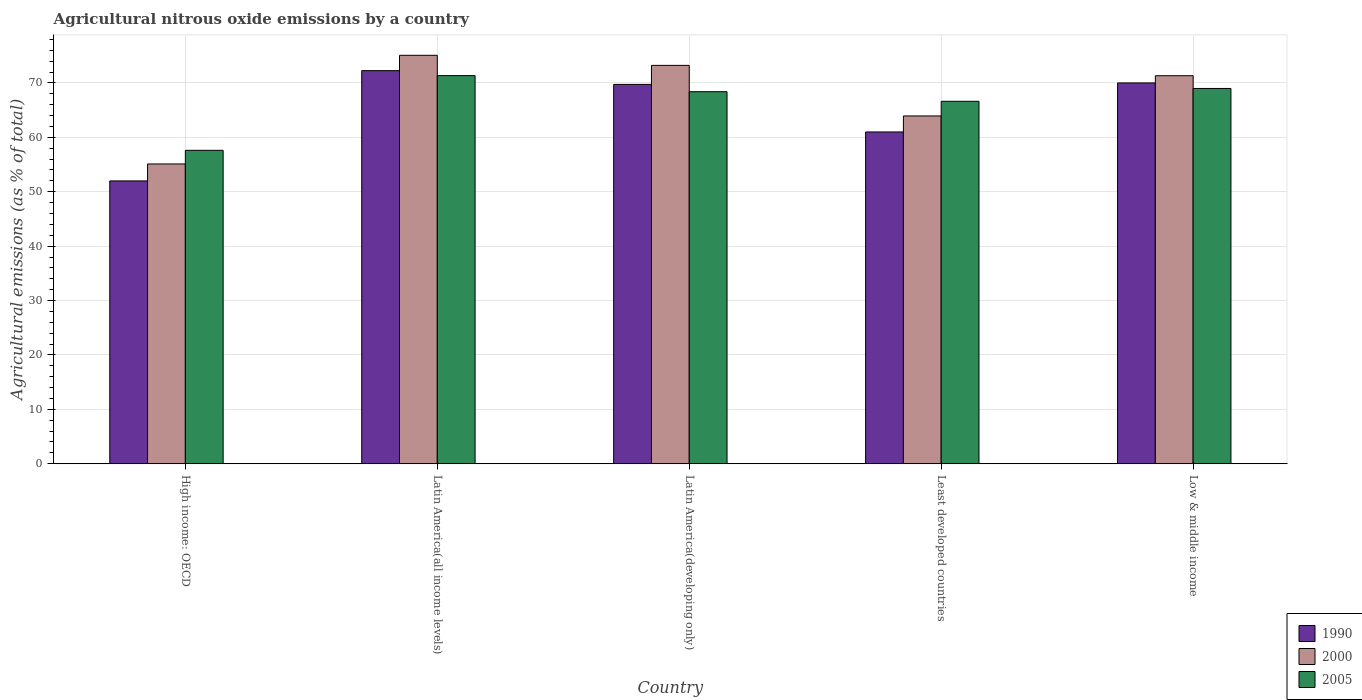How many different coloured bars are there?
Keep it short and to the point. 3. Are the number of bars on each tick of the X-axis equal?
Your answer should be compact. Yes. How many bars are there on the 2nd tick from the left?
Offer a terse response. 3. How many bars are there on the 1st tick from the right?
Your answer should be very brief. 3. What is the label of the 5th group of bars from the left?
Provide a short and direct response. Low & middle income. In how many cases, is the number of bars for a given country not equal to the number of legend labels?
Offer a very short reply. 0. What is the amount of agricultural nitrous oxide emitted in 2000 in Least developed countries?
Your answer should be compact. 63.93. Across all countries, what is the maximum amount of agricultural nitrous oxide emitted in 2000?
Provide a short and direct response. 75.08. Across all countries, what is the minimum amount of agricultural nitrous oxide emitted in 2000?
Make the answer very short. 55.1. In which country was the amount of agricultural nitrous oxide emitted in 2000 maximum?
Offer a very short reply. Latin America(all income levels). In which country was the amount of agricultural nitrous oxide emitted in 1990 minimum?
Keep it short and to the point. High income: OECD. What is the total amount of agricultural nitrous oxide emitted in 2000 in the graph?
Provide a succinct answer. 338.66. What is the difference between the amount of agricultural nitrous oxide emitted in 1990 in Latin America(all income levels) and that in Low & middle income?
Your response must be concise. 2.26. What is the difference between the amount of agricultural nitrous oxide emitted in 1990 in Least developed countries and the amount of agricultural nitrous oxide emitted in 2000 in Latin America(developing only)?
Your answer should be very brief. -12.24. What is the average amount of agricultural nitrous oxide emitted in 1990 per country?
Make the answer very short. 64.99. What is the difference between the amount of agricultural nitrous oxide emitted of/in 2005 and amount of agricultural nitrous oxide emitted of/in 2000 in Low & middle income?
Your answer should be compact. -2.34. What is the ratio of the amount of agricultural nitrous oxide emitted in 2005 in High income: OECD to that in Least developed countries?
Your response must be concise. 0.86. Is the difference between the amount of agricultural nitrous oxide emitted in 2005 in High income: OECD and Low & middle income greater than the difference between the amount of agricultural nitrous oxide emitted in 2000 in High income: OECD and Low & middle income?
Your response must be concise. Yes. What is the difference between the highest and the second highest amount of agricultural nitrous oxide emitted in 1990?
Keep it short and to the point. 2.53. What is the difference between the highest and the lowest amount of agricultural nitrous oxide emitted in 2000?
Provide a succinct answer. 19.97. Is the sum of the amount of agricultural nitrous oxide emitted in 2000 in High income: OECD and Latin America(all income levels) greater than the maximum amount of agricultural nitrous oxide emitted in 2005 across all countries?
Your response must be concise. Yes. What does the 1st bar from the left in Low & middle income represents?
Provide a succinct answer. 1990. What does the 1st bar from the right in High income: OECD represents?
Give a very brief answer. 2005. How many bars are there?
Make the answer very short. 15. Are the values on the major ticks of Y-axis written in scientific E-notation?
Provide a short and direct response. No. Does the graph contain grids?
Your answer should be compact. Yes. What is the title of the graph?
Make the answer very short. Agricultural nitrous oxide emissions by a country. What is the label or title of the Y-axis?
Your answer should be very brief. Agricultural emissions (as % of total). What is the Agricultural emissions (as % of total) of 1990 in High income: OECD?
Give a very brief answer. 51.99. What is the Agricultural emissions (as % of total) of 2000 in High income: OECD?
Offer a very short reply. 55.1. What is the Agricultural emissions (as % of total) in 2005 in High income: OECD?
Your answer should be very brief. 57.61. What is the Agricultural emissions (as % of total) in 1990 in Latin America(all income levels)?
Your answer should be compact. 72.26. What is the Agricultural emissions (as % of total) in 2000 in Latin America(all income levels)?
Make the answer very short. 75.08. What is the Agricultural emissions (as % of total) of 2005 in Latin America(all income levels)?
Ensure brevity in your answer.  71.34. What is the Agricultural emissions (as % of total) in 1990 in Latin America(developing only)?
Ensure brevity in your answer.  69.73. What is the Agricultural emissions (as % of total) in 2000 in Latin America(developing only)?
Keep it short and to the point. 73.22. What is the Agricultural emissions (as % of total) in 2005 in Latin America(developing only)?
Ensure brevity in your answer.  68.38. What is the Agricultural emissions (as % of total) of 1990 in Least developed countries?
Your answer should be very brief. 60.99. What is the Agricultural emissions (as % of total) of 2000 in Least developed countries?
Provide a short and direct response. 63.93. What is the Agricultural emissions (as % of total) of 2005 in Least developed countries?
Keep it short and to the point. 66.62. What is the Agricultural emissions (as % of total) in 1990 in Low & middle income?
Your answer should be compact. 70. What is the Agricultural emissions (as % of total) in 2000 in Low & middle income?
Offer a terse response. 71.32. What is the Agricultural emissions (as % of total) of 2005 in Low & middle income?
Your answer should be compact. 68.98. Across all countries, what is the maximum Agricultural emissions (as % of total) of 1990?
Give a very brief answer. 72.26. Across all countries, what is the maximum Agricultural emissions (as % of total) of 2000?
Give a very brief answer. 75.08. Across all countries, what is the maximum Agricultural emissions (as % of total) in 2005?
Offer a terse response. 71.34. Across all countries, what is the minimum Agricultural emissions (as % of total) in 1990?
Give a very brief answer. 51.99. Across all countries, what is the minimum Agricultural emissions (as % of total) in 2000?
Your answer should be compact. 55.1. Across all countries, what is the minimum Agricultural emissions (as % of total) of 2005?
Provide a succinct answer. 57.61. What is the total Agricultural emissions (as % of total) of 1990 in the graph?
Make the answer very short. 324.96. What is the total Agricultural emissions (as % of total) of 2000 in the graph?
Offer a terse response. 338.66. What is the total Agricultural emissions (as % of total) of 2005 in the graph?
Offer a terse response. 332.94. What is the difference between the Agricultural emissions (as % of total) of 1990 in High income: OECD and that in Latin America(all income levels)?
Your response must be concise. -20.27. What is the difference between the Agricultural emissions (as % of total) of 2000 in High income: OECD and that in Latin America(all income levels)?
Make the answer very short. -19.97. What is the difference between the Agricultural emissions (as % of total) of 2005 in High income: OECD and that in Latin America(all income levels)?
Offer a terse response. -13.73. What is the difference between the Agricultural emissions (as % of total) of 1990 in High income: OECD and that in Latin America(developing only)?
Offer a terse response. -17.74. What is the difference between the Agricultural emissions (as % of total) of 2000 in High income: OECD and that in Latin America(developing only)?
Give a very brief answer. -18.12. What is the difference between the Agricultural emissions (as % of total) in 2005 in High income: OECD and that in Latin America(developing only)?
Your answer should be compact. -10.77. What is the difference between the Agricultural emissions (as % of total) in 1990 in High income: OECD and that in Least developed countries?
Your response must be concise. -9. What is the difference between the Agricultural emissions (as % of total) in 2000 in High income: OECD and that in Least developed countries?
Your answer should be very brief. -8.82. What is the difference between the Agricultural emissions (as % of total) in 2005 in High income: OECD and that in Least developed countries?
Provide a short and direct response. -9.01. What is the difference between the Agricultural emissions (as % of total) in 1990 in High income: OECD and that in Low & middle income?
Provide a succinct answer. -18.01. What is the difference between the Agricultural emissions (as % of total) of 2000 in High income: OECD and that in Low & middle income?
Your response must be concise. -16.22. What is the difference between the Agricultural emissions (as % of total) in 2005 in High income: OECD and that in Low & middle income?
Make the answer very short. -11.37. What is the difference between the Agricultural emissions (as % of total) of 1990 in Latin America(all income levels) and that in Latin America(developing only)?
Make the answer very short. 2.53. What is the difference between the Agricultural emissions (as % of total) of 2000 in Latin America(all income levels) and that in Latin America(developing only)?
Offer a terse response. 1.86. What is the difference between the Agricultural emissions (as % of total) in 2005 in Latin America(all income levels) and that in Latin America(developing only)?
Provide a succinct answer. 2.96. What is the difference between the Agricultural emissions (as % of total) in 1990 in Latin America(all income levels) and that in Least developed countries?
Your answer should be compact. 11.27. What is the difference between the Agricultural emissions (as % of total) of 2000 in Latin America(all income levels) and that in Least developed countries?
Give a very brief answer. 11.15. What is the difference between the Agricultural emissions (as % of total) of 2005 in Latin America(all income levels) and that in Least developed countries?
Provide a succinct answer. 4.72. What is the difference between the Agricultural emissions (as % of total) of 1990 in Latin America(all income levels) and that in Low & middle income?
Give a very brief answer. 2.26. What is the difference between the Agricultural emissions (as % of total) in 2000 in Latin America(all income levels) and that in Low & middle income?
Give a very brief answer. 3.75. What is the difference between the Agricultural emissions (as % of total) of 2005 in Latin America(all income levels) and that in Low & middle income?
Offer a terse response. 2.36. What is the difference between the Agricultural emissions (as % of total) in 1990 in Latin America(developing only) and that in Least developed countries?
Your response must be concise. 8.74. What is the difference between the Agricultural emissions (as % of total) in 2000 in Latin America(developing only) and that in Least developed countries?
Your answer should be compact. 9.29. What is the difference between the Agricultural emissions (as % of total) of 2005 in Latin America(developing only) and that in Least developed countries?
Give a very brief answer. 1.76. What is the difference between the Agricultural emissions (as % of total) in 1990 in Latin America(developing only) and that in Low & middle income?
Keep it short and to the point. -0.27. What is the difference between the Agricultural emissions (as % of total) in 2000 in Latin America(developing only) and that in Low & middle income?
Provide a succinct answer. 1.9. What is the difference between the Agricultural emissions (as % of total) in 2005 in Latin America(developing only) and that in Low & middle income?
Your answer should be very brief. -0.6. What is the difference between the Agricultural emissions (as % of total) in 1990 in Least developed countries and that in Low & middle income?
Offer a very short reply. -9.01. What is the difference between the Agricultural emissions (as % of total) in 2000 in Least developed countries and that in Low & middle income?
Provide a short and direct response. -7.39. What is the difference between the Agricultural emissions (as % of total) of 2005 in Least developed countries and that in Low & middle income?
Offer a very short reply. -2.36. What is the difference between the Agricultural emissions (as % of total) in 1990 in High income: OECD and the Agricultural emissions (as % of total) in 2000 in Latin America(all income levels)?
Your answer should be very brief. -23.09. What is the difference between the Agricultural emissions (as % of total) in 1990 in High income: OECD and the Agricultural emissions (as % of total) in 2005 in Latin America(all income levels)?
Your answer should be very brief. -19.35. What is the difference between the Agricultural emissions (as % of total) in 2000 in High income: OECD and the Agricultural emissions (as % of total) in 2005 in Latin America(all income levels)?
Keep it short and to the point. -16.24. What is the difference between the Agricultural emissions (as % of total) in 1990 in High income: OECD and the Agricultural emissions (as % of total) in 2000 in Latin America(developing only)?
Provide a succinct answer. -21.23. What is the difference between the Agricultural emissions (as % of total) of 1990 in High income: OECD and the Agricultural emissions (as % of total) of 2005 in Latin America(developing only)?
Ensure brevity in your answer.  -16.39. What is the difference between the Agricultural emissions (as % of total) of 2000 in High income: OECD and the Agricultural emissions (as % of total) of 2005 in Latin America(developing only)?
Your answer should be very brief. -13.28. What is the difference between the Agricultural emissions (as % of total) of 1990 in High income: OECD and the Agricultural emissions (as % of total) of 2000 in Least developed countries?
Keep it short and to the point. -11.94. What is the difference between the Agricultural emissions (as % of total) of 1990 in High income: OECD and the Agricultural emissions (as % of total) of 2005 in Least developed countries?
Make the answer very short. -14.63. What is the difference between the Agricultural emissions (as % of total) in 2000 in High income: OECD and the Agricultural emissions (as % of total) in 2005 in Least developed countries?
Offer a terse response. -11.52. What is the difference between the Agricultural emissions (as % of total) in 1990 in High income: OECD and the Agricultural emissions (as % of total) in 2000 in Low & middle income?
Your answer should be very brief. -19.34. What is the difference between the Agricultural emissions (as % of total) in 1990 in High income: OECD and the Agricultural emissions (as % of total) in 2005 in Low & middle income?
Give a very brief answer. -16.99. What is the difference between the Agricultural emissions (as % of total) of 2000 in High income: OECD and the Agricultural emissions (as % of total) of 2005 in Low & middle income?
Provide a short and direct response. -13.88. What is the difference between the Agricultural emissions (as % of total) in 1990 in Latin America(all income levels) and the Agricultural emissions (as % of total) in 2000 in Latin America(developing only)?
Give a very brief answer. -0.97. What is the difference between the Agricultural emissions (as % of total) in 1990 in Latin America(all income levels) and the Agricultural emissions (as % of total) in 2005 in Latin America(developing only)?
Offer a terse response. 3.87. What is the difference between the Agricultural emissions (as % of total) in 2000 in Latin America(all income levels) and the Agricultural emissions (as % of total) in 2005 in Latin America(developing only)?
Offer a very short reply. 6.69. What is the difference between the Agricultural emissions (as % of total) in 1990 in Latin America(all income levels) and the Agricultural emissions (as % of total) in 2000 in Least developed countries?
Give a very brief answer. 8.33. What is the difference between the Agricultural emissions (as % of total) in 1990 in Latin America(all income levels) and the Agricultural emissions (as % of total) in 2005 in Least developed countries?
Your response must be concise. 5.64. What is the difference between the Agricultural emissions (as % of total) in 2000 in Latin America(all income levels) and the Agricultural emissions (as % of total) in 2005 in Least developed countries?
Offer a terse response. 8.46. What is the difference between the Agricultural emissions (as % of total) in 1990 in Latin America(all income levels) and the Agricultural emissions (as % of total) in 2000 in Low & middle income?
Offer a very short reply. 0.93. What is the difference between the Agricultural emissions (as % of total) of 1990 in Latin America(all income levels) and the Agricultural emissions (as % of total) of 2005 in Low & middle income?
Your answer should be very brief. 3.27. What is the difference between the Agricultural emissions (as % of total) of 2000 in Latin America(all income levels) and the Agricultural emissions (as % of total) of 2005 in Low & middle income?
Your response must be concise. 6.1. What is the difference between the Agricultural emissions (as % of total) of 1990 in Latin America(developing only) and the Agricultural emissions (as % of total) of 2000 in Least developed countries?
Give a very brief answer. 5.8. What is the difference between the Agricultural emissions (as % of total) in 1990 in Latin America(developing only) and the Agricultural emissions (as % of total) in 2005 in Least developed countries?
Your response must be concise. 3.11. What is the difference between the Agricultural emissions (as % of total) in 2000 in Latin America(developing only) and the Agricultural emissions (as % of total) in 2005 in Least developed countries?
Give a very brief answer. 6.6. What is the difference between the Agricultural emissions (as % of total) of 1990 in Latin America(developing only) and the Agricultural emissions (as % of total) of 2000 in Low & middle income?
Offer a very short reply. -1.59. What is the difference between the Agricultural emissions (as % of total) of 1990 in Latin America(developing only) and the Agricultural emissions (as % of total) of 2005 in Low & middle income?
Offer a terse response. 0.75. What is the difference between the Agricultural emissions (as % of total) in 2000 in Latin America(developing only) and the Agricultural emissions (as % of total) in 2005 in Low & middle income?
Keep it short and to the point. 4.24. What is the difference between the Agricultural emissions (as % of total) in 1990 in Least developed countries and the Agricultural emissions (as % of total) in 2000 in Low & middle income?
Keep it short and to the point. -10.34. What is the difference between the Agricultural emissions (as % of total) in 1990 in Least developed countries and the Agricultural emissions (as % of total) in 2005 in Low & middle income?
Offer a very short reply. -8. What is the difference between the Agricultural emissions (as % of total) of 2000 in Least developed countries and the Agricultural emissions (as % of total) of 2005 in Low & middle income?
Offer a very short reply. -5.05. What is the average Agricultural emissions (as % of total) of 1990 per country?
Provide a short and direct response. 64.99. What is the average Agricultural emissions (as % of total) in 2000 per country?
Your answer should be very brief. 67.73. What is the average Agricultural emissions (as % of total) in 2005 per country?
Your answer should be compact. 66.59. What is the difference between the Agricultural emissions (as % of total) in 1990 and Agricultural emissions (as % of total) in 2000 in High income: OECD?
Give a very brief answer. -3.12. What is the difference between the Agricultural emissions (as % of total) in 1990 and Agricultural emissions (as % of total) in 2005 in High income: OECD?
Keep it short and to the point. -5.62. What is the difference between the Agricultural emissions (as % of total) in 2000 and Agricultural emissions (as % of total) in 2005 in High income: OECD?
Offer a very short reply. -2.51. What is the difference between the Agricultural emissions (as % of total) of 1990 and Agricultural emissions (as % of total) of 2000 in Latin America(all income levels)?
Your answer should be compact. -2.82. What is the difference between the Agricultural emissions (as % of total) of 1990 and Agricultural emissions (as % of total) of 2005 in Latin America(all income levels)?
Offer a very short reply. 0.91. What is the difference between the Agricultural emissions (as % of total) in 2000 and Agricultural emissions (as % of total) in 2005 in Latin America(all income levels)?
Your answer should be very brief. 3.74. What is the difference between the Agricultural emissions (as % of total) in 1990 and Agricultural emissions (as % of total) in 2000 in Latin America(developing only)?
Your response must be concise. -3.49. What is the difference between the Agricultural emissions (as % of total) of 1990 and Agricultural emissions (as % of total) of 2005 in Latin America(developing only)?
Offer a terse response. 1.35. What is the difference between the Agricultural emissions (as % of total) in 2000 and Agricultural emissions (as % of total) in 2005 in Latin America(developing only)?
Provide a short and direct response. 4.84. What is the difference between the Agricultural emissions (as % of total) in 1990 and Agricultural emissions (as % of total) in 2000 in Least developed countries?
Your answer should be very brief. -2.94. What is the difference between the Agricultural emissions (as % of total) of 1990 and Agricultural emissions (as % of total) of 2005 in Least developed countries?
Make the answer very short. -5.63. What is the difference between the Agricultural emissions (as % of total) in 2000 and Agricultural emissions (as % of total) in 2005 in Least developed countries?
Give a very brief answer. -2.69. What is the difference between the Agricultural emissions (as % of total) of 1990 and Agricultural emissions (as % of total) of 2000 in Low & middle income?
Give a very brief answer. -1.33. What is the difference between the Agricultural emissions (as % of total) of 1990 and Agricultural emissions (as % of total) of 2005 in Low & middle income?
Your answer should be compact. 1.02. What is the difference between the Agricultural emissions (as % of total) of 2000 and Agricultural emissions (as % of total) of 2005 in Low & middle income?
Offer a very short reply. 2.34. What is the ratio of the Agricultural emissions (as % of total) of 1990 in High income: OECD to that in Latin America(all income levels)?
Offer a very short reply. 0.72. What is the ratio of the Agricultural emissions (as % of total) of 2000 in High income: OECD to that in Latin America(all income levels)?
Offer a terse response. 0.73. What is the ratio of the Agricultural emissions (as % of total) of 2005 in High income: OECD to that in Latin America(all income levels)?
Your response must be concise. 0.81. What is the ratio of the Agricultural emissions (as % of total) of 1990 in High income: OECD to that in Latin America(developing only)?
Offer a very short reply. 0.75. What is the ratio of the Agricultural emissions (as % of total) in 2000 in High income: OECD to that in Latin America(developing only)?
Give a very brief answer. 0.75. What is the ratio of the Agricultural emissions (as % of total) of 2005 in High income: OECD to that in Latin America(developing only)?
Your answer should be compact. 0.84. What is the ratio of the Agricultural emissions (as % of total) in 1990 in High income: OECD to that in Least developed countries?
Ensure brevity in your answer.  0.85. What is the ratio of the Agricultural emissions (as % of total) of 2000 in High income: OECD to that in Least developed countries?
Your answer should be compact. 0.86. What is the ratio of the Agricultural emissions (as % of total) of 2005 in High income: OECD to that in Least developed countries?
Your response must be concise. 0.86. What is the ratio of the Agricultural emissions (as % of total) in 1990 in High income: OECD to that in Low & middle income?
Your answer should be compact. 0.74. What is the ratio of the Agricultural emissions (as % of total) of 2000 in High income: OECD to that in Low & middle income?
Make the answer very short. 0.77. What is the ratio of the Agricultural emissions (as % of total) in 2005 in High income: OECD to that in Low & middle income?
Provide a short and direct response. 0.84. What is the ratio of the Agricultural emissions (as % of total) in 1990 in Latin America(all income levels) to that in Latin America(developing only)?
Offer a terse response. 1.04. What is the ratio of the Agricultural emissions (as % of total) in 2000 in Latin America(all income levels) to that in Latin America(developing only)?
Your answer should be very brief. 1.03. What is the ratio of the Agricultural emissions (as % of total) of 2005 in Latin America(all income levels) to that in Latin America(developing only)?
Your answer should be compact. 1.04. What is the ratio of the Agricultural emissions (as % of total) of 1990 in Latin America(all income levels) to that in Least developed countries?
Give a very brief answer. 1.18. What is the ratio of the Agricultural emissions (as % of total) in 2000 in Latin America(all income levels) to that in Least developed countries?
Provide a succinct answer. 1.17. What is the ratio of the Agricultural emissions (as % of total) of 2005 in Latin America(all income levels) to that in Least developed countries?
Your answer should be very brief. 1.07. What is the ratio of the Agricultural emissions (as % of total) of 1990 in Latin America(all income levels) to that in Low & middle income?
Provide a short and direct response. 1.03. What is the ratio of the Agricultural emissions (as % of total) in 2000 in Latin America(all income levels) to that in Low & middle income?
Give a very brief answer. 1.05. What is the ratio of the Agricultural emissions (as % of total) in 2005 in Latin America(all income levels) to that in Low & middle income?
Keep it short and to the point. 1.03. What is the ratio of the Agricultural emissions (as % of total) of 1990 in Latin America(developing only) to that in Least developed countries?
Make the answer very short. 1.14. What is the ratio of the Agricultural emissions (as % of total) of 2000 in Latin America(developing only) to that in Least developed countries?
Keep it short and to the point. 1.15. What is the ratio of the Agricultural emissions (as % of total) in 2005 in Latin America(developing only) to that in Least developed countries?
Your response must be concise. 1.03. What is the ratio of the Agricultural emissions (as % of total) of 1990 in Latin America(developing only) to that in Low & middle income?
Provide a succinct answer. 1. What is the ratio of the Agricultural emissions (as % of total) of 2000 in Latin America(developing only) to that in Low & middle income?
Your answer should be very brief. 1.03. What is the ratio of the Agricultural emissions (as % of total) of 1990 in Least developed countries to that in Low & middle income?
Provide a succinct answer. 0.87. What is the ratio of the Agricultural emissions (as % of total) of 2000 in Least developed countries to that in Low & middle income?
Provide a succinct answer. 0.9. What is the ratio of the Agricultural emissions (as % of total) in 2005 in Least developed countries to that in Low & middle income?
Keep it short and to the point. 0.97. What is the difference between the highest and the second highest Agricultural emissions (as % of total) in 1990?
Keep it short and to the point. 2.26. What is the difference between the highest and the second highest Agricultural emissions (as % of total) of 2000?
Offer a terse response. 1.86. What is the difference between the highest and the second highest Agricultural emissions (as % of total) in 2005?
Keep it short and to the point. 2.36. What is the difference between the highest and the lowest Agricultural emissions (as % of total) in 1990?
Provide a succinct answer. 20.27. What is the difference between the highest and the lowest Agricultural emissions (as % of total) of 2000?
Ensure brevity in your answer.  19.97. What is the difference between the highest and the lowest Agricultural emissions (as % of total) of 2005?
Give a very brief answer. 13.73. 